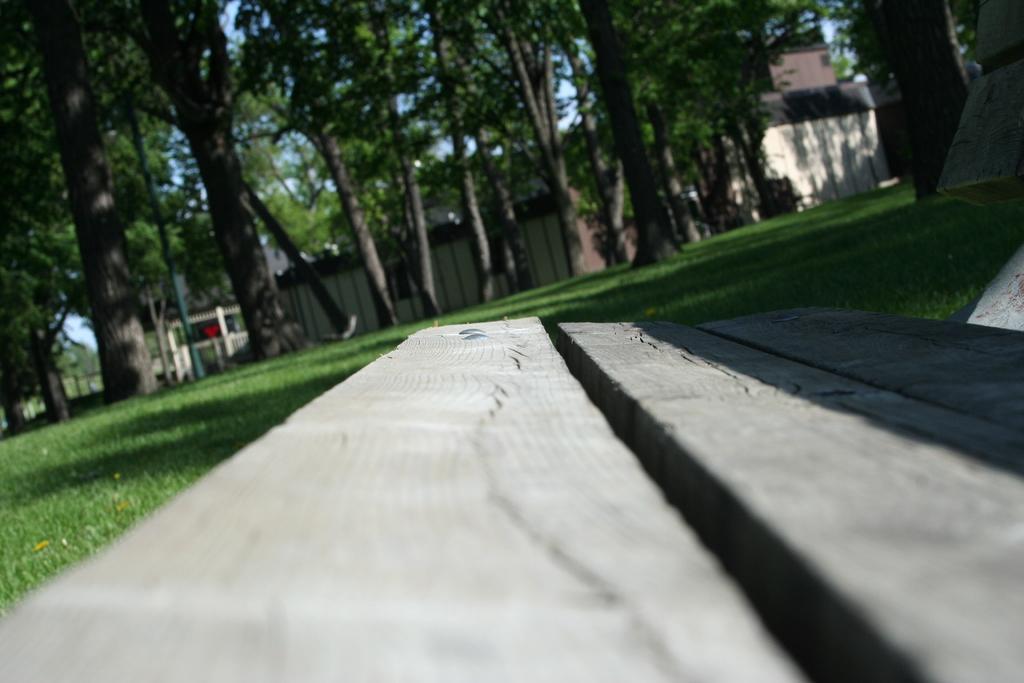Could you give a brief overview of what you see in this image? In this image we can see a bench and at the background of the image there are some trees, houses and clear sky. 